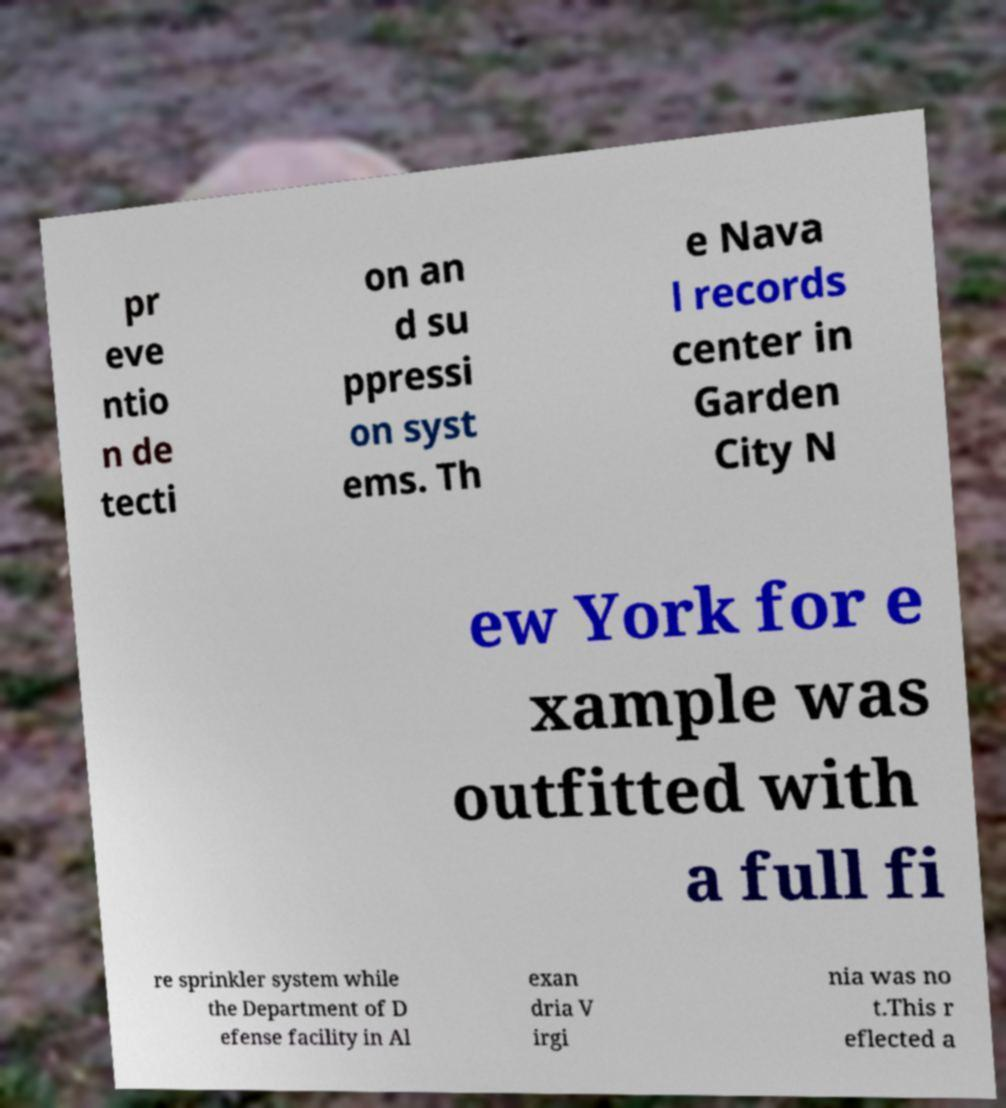Could you assist in decoding the text presented in this image and type it out clearly? pr eve ntio n de tecti on an d su ppressi on syst ems. Th e Nava l records center in Garden City N ew York for e xample was outfitted with a full fi re sprinkler system while the Department of D efense facility in Al exan dria V irgi nia was no t.This r eflected a 